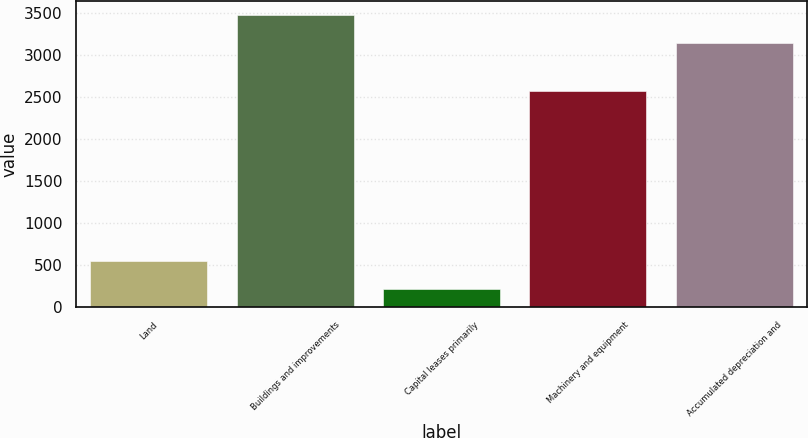<chart> <loc_0><loc_0><loc_500><loc_500><bar_chart><fcel>Land<fcel>Buildings and improvements<fcel>Capital leases primarily<fcel>Machinery and equipment<fcel>Accumulated depreciation and<nl><fcel>543.8<fcel>3468.8<fcel>221<fcel>2566<fcel>3146<nl></chart> 